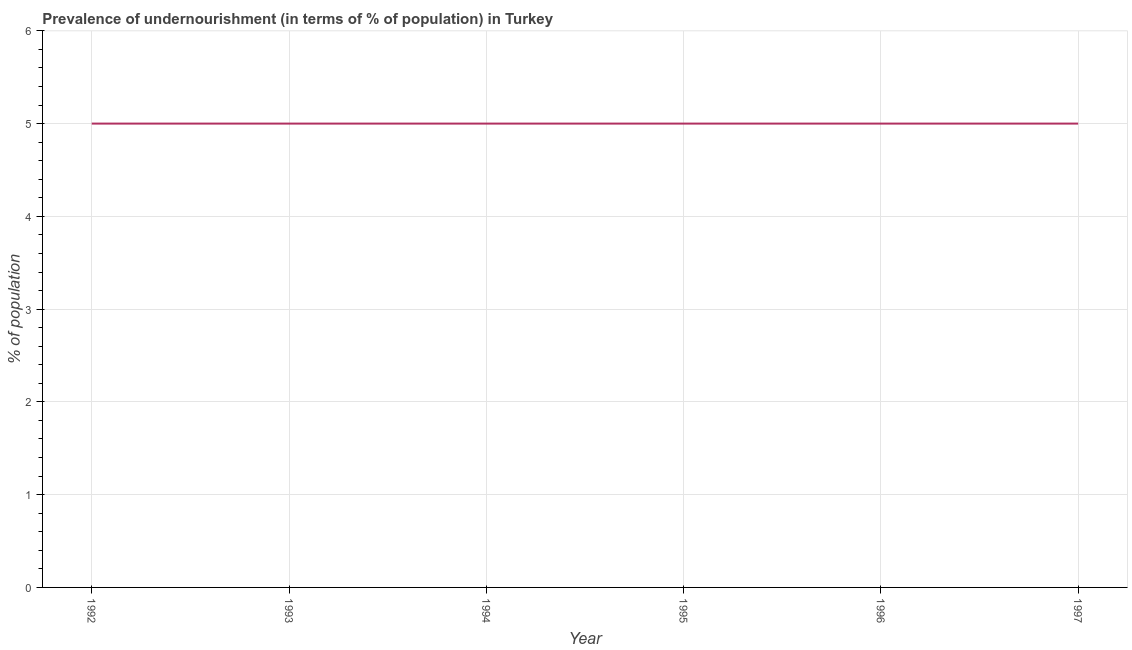What is the percentage of undernourished population in 1997?
Make the answer very short. 5. Across all years, what is the maximum percentage of undernourished population?
Give a very brief answer. 5. Across all years, what is the minimum percentage of undernourished population?
Give a very brief answer. 5. In which year was the percentage of undernourished population minimum?
Offer a terse response. 1992. What is the sum of the percentage of undernourished population?
Give a very brief answer. 30. What is the average percentage of undernourished population per year?
Provide a succinct answer. 5. What is the median percentage of undernourished population?
Your response must be concise. 5. Is the percentage of undernourished population in 1992 less than that in 1994?
Provide a short and direct response. No. Is the sum of the percentage of undernourished population in 1992 and 1994 greater than the maximum percentage of undernourished population across all years?
Offer a terse response. Yes. What is the difference between the highest and the lowest percentage of undernourished population?
Offer a very short reply. 0. In how many years, is the percentage of undernourished population greater than the average percentage of undernourished population taken over all years?
Your response must be concise. 0. Does the percentage of undernourished population monotonically increase over the years?
Your answer should be compact. No. How many lines are there?
Ensure brevity in your answer.  1. Does the graph contain any zero values?
Your response must be concise. No. What is the title of the graph?
Keep it short and to the point. Prevalence of undernourishment (in terms of % of population) in Turkey. What is the label or title of the Y-axis?
Your response must be concise. % of population. What is the % of population of 1992?
Keep it short and to the point. 5. What is the % of population in 1994?
Keep it short and to the point. 5. What is the % of population in 1997?
Keep it short and to the point. 5. What is the difference between the % of population in 1992 and 1993?
Your response must be concise. 0. What is the difference between the % of population in 1992 and 1995?
Offer a terse response. 0. What is the difference between the % of population in 1992 and 1996?
Ensure brevity in your answer.  0. What is the difference between the % of population in 1993 and 1994?
Keep it short and to the point. 0. What is the difference between the % of population in 1993 and 1995?
Offer a terse response. 0. What is the difference between the % of population in 1994 and 1997?
Ensure brevity in your answer.  0. What is the ratio of the % of population in 1992 to that in 1994?
Keep it short and to the point. 1. What is the ratio of the % of population in 1992 to that in 1996?
Provide a short and direct response. 1. What is the ratio of the % of population in 1992 to that in 1997?
Your answer should be very brief. 1. What is the ratio of the % of population in 1993 to that in 1995?
Offer a very short reply. 1. What is the ratio of the % of population in 1993 to that in 1997?
Offer a very short reply. 1. What is the ratio of the % of population in 1994 to that in 1995?
Provide a short and direct response. 1. What is the ratio of the % of population in 1994 to that in 1996?
Keep it short and to the point. 1. 